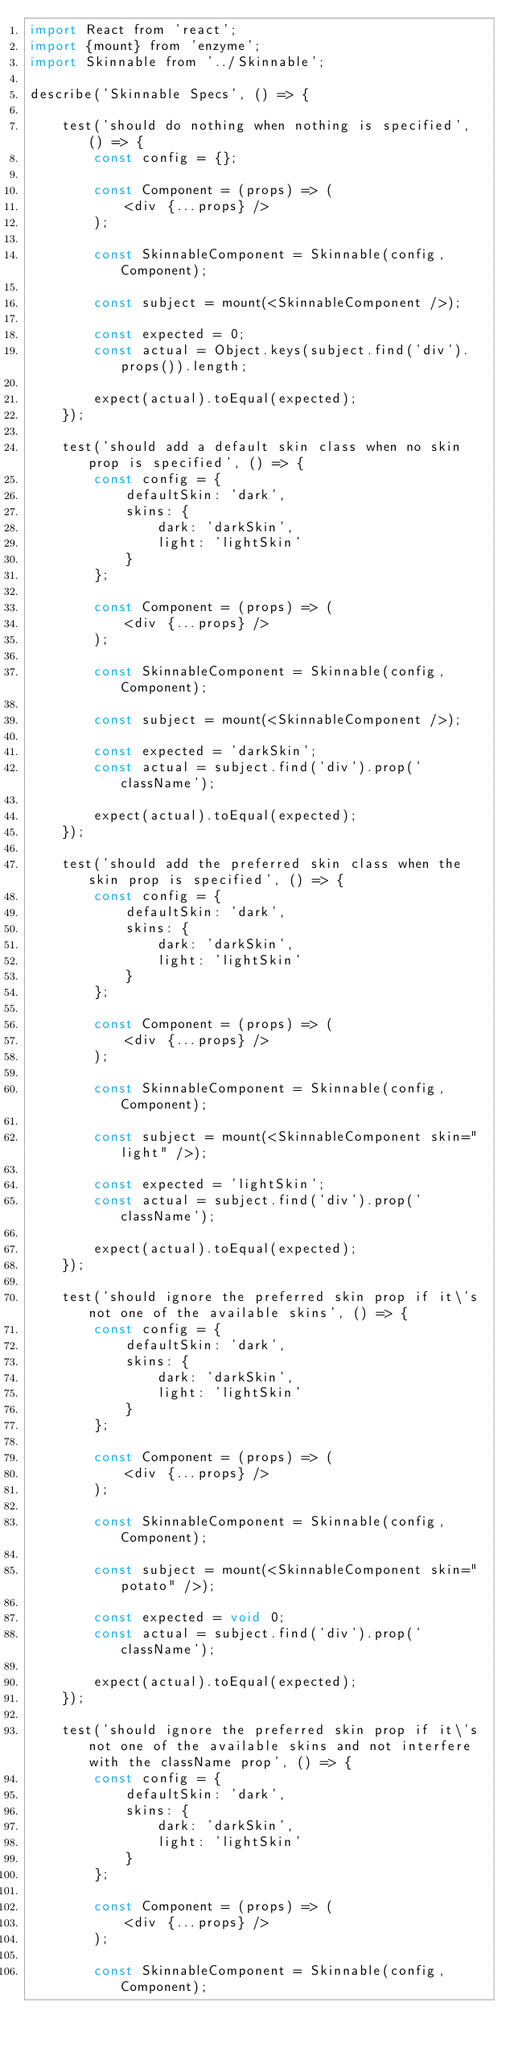<code> <loc_0><loc_0><loc_500><loc_500><_JavaScript_>import React from 'react';
import {mount} from 'enzyme';
import Skinnable from '../Skinnable';

describe('Skinnable Specs', () => {

	test('should do nothing when nothing is specified', () => {
		const config = {};

		const Component = (props) => (
			<div {...props} />
		);

		const SkinnableComponent = Skinnable(config, Component);

		const subject = mount(<SkinnableComponent />);

		const expected = 0;
		const actual = Object.keys(subject.find('div').props()).length;

		expect(actual).toEqual(expected);
	});

	test('should add a default skin class when no skin prop is specified', () => {
		const config = {
			defaultSkin: 'dark',
			skins: {
				dark: 'darkSkin',
				light: 'lightSkin'
			}
		};

		const Component = (props) => (
			<div {...props} />
		);

		const SkinnableComponent = Skinnable(config, Component);

		const subject = mount(<SkinnableComponent />);

		const expected = 'darkSkin';
		const actual = subject.find('div').prop('className');

		expect(actual).toEqual(expected);
	});

	test('should add the preferred skin class when the skin prop is specified', () => {
		const config = {
			defaultSkin: 'dark',
			skins: {
				dark: 'darkSkin',
				light: 'lightSkin'
			}
		};

		const Component = (props) => (
			<div {...props} />
		);

		const SkinnableComponent = Skinnable(config, Component);

		const subject = mount(<SkinnableComponent skin="light" />);

		const expected = 'lightSkin';
		const actual = subject.find('div').prop('className');

		expect(actual).toEqual(expected);
	});

	test('should ignore the preferred skin prop if it\'s not one of the available skins', () => {
		const config = {
			defaultSkin: 'dark',
			skins: {
				dark: 'darkSkin',
				light: 'lightSkin'
			}
		};

		const Component = (props) => (
			<div {...props} />
		);

		const SkinnableComponent = Skinnable(config, Component);

		const subject = mount(<SkinnableComponent skin="potato" />);

		const expected = void 0;
		const actual = subject.find('div').prop('className');

		expect(actual).toEqual(expected);
	});

	test('should ignore the preferred skin prop if it\'s not one of the available skins and not interfere with the className prop', () => {
		const config = {
			defaultSkin: 'dark',
			skins: {
				dark: 'darkSkin',
				light: 'lightSkin'
			}
		};

		const Component = (props) => (
			<div {...props} />
		);

		const SkinnableComponent = Skinnable(config, Component);
</code> 